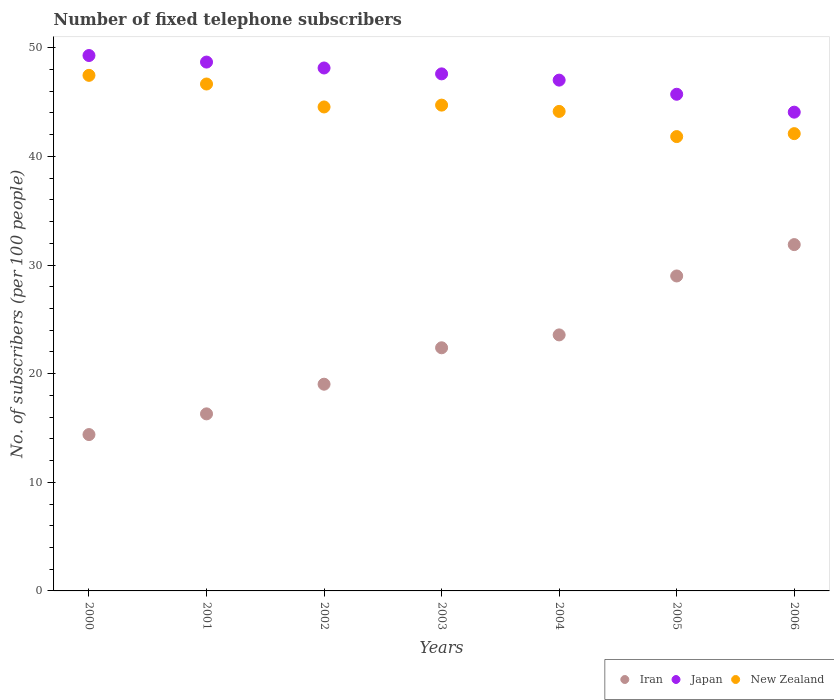Is the number of dotlines equal to the number of legend labels?
Your answer should be very brief. Yes. What is the number of fixed telephone subscribers in New Zealand in 2003?
Make the answer very short. 44.72. Across all years, what is the maximum number of fixed telephone subscribers in New Zealand?
Provide a succinct answer. 47.46. Across all years, what is the minimum number of fixed telephone subscribers in New Zealand?
Offer a very short reply. 41.82. In which year was the number of fixed telephone subscribers in New Zealand minimum?
Ensure brevity in your answer.  2005. What is the total number of fixed telephone subscribers in Japan in the graph?
Offer a terse response. 330.51. What is the difference between the number of fixed telephone subscribers in New Zealand in 2000 and that in 2004?
Give a very brief answer. 3.32. What is the difference between the number of fixed telephone subscribers in Iran in 2003 and the number of fixed telephone subscribers in New Zealand in 2001?
Give a very brief answer. -24.28. What is the average number of fixed telephone subscribers in Iran per year?
Offer a terse response. 22.36. In the year 2004, what is the difference between the number of fixed telephone subscribers in New Zealand and number of fixed telephone subscribers in Iran?
Your answer should be compact. 20.57. In how many years, is the number of fixed telephone subscribers in New Zealand greater than 14?
Ensure brevity in your answer.  7. What is the ratio of the number of fixed telephone subscribers in Japan in 2000 to that in 2005?
Your response must be concise. 1.08. Is the difference between the number of fixed telephone subscribers in New Zealand in 2002 and 2004 greater than the difference between the number of fixed telephone subscribers in Iran in 2002 and 2004?
Offer a very short reply. Yes. What is the difference between the highest and the second highest number of fixed telephone subscribers in Japan?
Offer a very short reply. 0.6. What is the difference between the highest and the lowest number of fixed telephone subscribers in Japan?
Provide a succinct answer. 5.21. In how many years, is the number of fixed telephone subscribers in New Zealand greater than the average number of fixed telephone subscribers in New Zealand taken over all years?
Your answer should be compact. 4. Is the sum of the number of fixed telephone subscribers in Japan in 2003 and 2005 greater than the maximum number of fixed telephone subscribers in Iran across all years?
Give a very brief answer. Yes. Is it the case that in every year, the sum of the number of fixed telephone subscribers in Japan and number of fixed telephone subscribers in New Zealand  is greater than the number of fixed telephone subscribers in Iran?
Your answer should be very brief. Yes. Is the number of fixed telephone subscribers in Iran strictly greater than the number of fixed telephone subscribers in New Zealand over the years?
Offer a terse response. No. Is the number of fixed telephone subscribers in Japan strictly less than the number of fixed telephone subscribers in New Zealand over the years?
Give a very brief answer. No. How many years are there in the graph?
Provide a succinct answer. 7. Are the values on the major ticks of Y-axis written in scientific E-notation?
Your response must be concise. No. Does the graph contain any zero values?
Keep it short and to the point. No. Does the graph contain grids?
Ensure brevity in your answer.  No. Where does the legend appear in the graph?
Provide a succinct answer. Bottom right. What is the title of the graph?
Give a very brief answer. Number of fixed telephone subscribers. What is the label or title of the X-axis?
Provide a short and direct response. Years. What is the label or title of the Y-axis?
Make the answer very short. No. of subscribers (per 100 people). What is the No. of subscribers (per 100 people) of Iran in 2000?
Keep it short and to the point. 14.39. What is the No. of subscribers (per 100 people) in Japan in 2000?
Offer a terse response. 49.28. What is the No. of subscribers (per 100 people) in New Zealand in 2000?
Your response must be concise. 47.46. What is the No. of subscribers (per 100 people) in Iran in 2001?
Your response must be concise. 16.3. What is the No. of subscribers (per 100 people) in Japan in 2001?
Provide a succinct answer. 48.68. What is the No. of subscribers (per 100 people) in New Zealand in 2001?
Your answer should be compact. 46.66. What is the No. of subscribers (per 100 people) of Iran in 2002?
Keep it short and to the point. 19.03. What is the No. of subscribers (per 100 people) of Japan in 2002?
Your answer should be very brief. 48.14. What is the No. of subscribers (per 100 people) in New Zealand in 2002?
Keep it short and to the point. 44.55. What is the No. of subscribers (per 100 people) in Iran in 2003?
Provide a succinct answer. 22.38. What is the No. of subscribers (per 100 people) of Japan in 2003?
Keep it short and to the point. 47.6. What is the No. of subscribers (per 100 people) of New Zealand in 2003?
Provide a succinct answer. 44.72. What is the No. of subscribers (per 100 people) in Iran in 2004?
Offer a very short reply. 23.57. What is the No. of subscribers (per 100 people) of Japan in 2004?
Provide a short and direct response. 47.02. What is the No. of subscribers (per 100 people) of New Zealand in 2004?
Keep it short and to the point. 44.14. What is the No. of subscribers (per 100 people) of Iran in 2005?
Offer a very short reply. 28.99. What is the No. of subscribers (per 100 people) of Japan in 2005?
Your response must be concise. 45.72. What is the No. of subscribers (per 100 people) of New Zealand in 2005?
Offer a terse response. 41.82. What is the No. of subscribers (per 100 people) of Iran in 2006?
Your answer should be very brief. 31.88. What is the No. of subscribers (per 100 people) in Japan in 2006?
Provide a short and direct response. 44.07. What is the No. of subscribers (per 100 people) in New Zealand in 2006?
Provide a short and direct response. 42.09. Across all years, what is the maximum No. of subscribers (per 100 people) of Iran?
Give a very brief answer. 31.88. Across all years, what is the maximum No. of subscribers (per 100 people) of Japan?
Provide a succinct answer. 49.28. Across all years, what is the maximum No. of subscribers (per 100 people) of New Zealand?
Give a very brief answer. 47.46. Across all years, what is the minimum No. of subscribers (per 100 people) in Iran?
Make the answer very short. 14.39. Across all years, what is the minimum No. of subscribers (per 100 people) in Japan?
Offer a terse response. 44.07. Across all years, what is the minimum No. of subscribers (per 100 people) of New Zealand?
Offer a terse response. 41.82. What is the total No. of subscribers (per 100 people) in Iran in the graph?
Your answer should be compact. 156.54. What is the total No. of subscribers (per 100 people) in Japan in the graph?
Provide a succinct answer. 330.51. What is the total No. of subscribers (per 100 people) in New Zealand in the graph?
Ensure brevity in your answer.  311.45. What is the difference between the No. of subscribers (per 100 people) of Iran in 2000 and that in 2001?
Offer a very short reply. -1.91. What is the difference between the No. of subscribers (per 100 people) in Japan in 2000 and that in 2001?
Provide a succinct answer. 0.6. What is the difference between the No. of subscribers (per 100 people) in New Zealand in 2000 and that in 2001?
Your response must be concise. 0.8. What is the difference between the No. of subscribers (per 100 people) in Iran in 2000 and that in 2002?
Provide a succinct answer. -4.64. What is the difference between the No. of subscribers (per 100 people) of Japan in 2000 and that in 2002?
Keep it short and to the point. 1.15. What is the difference between the No. of subscribers (per 100 people) in New Zealand in 2000 and that in 2002?
Make the answer very short. 2.91. What is the difference between the No. of subscribers (per 100 people) in Iran in 2000 and that in 2003?
Your answer should be compact. -7.99. What is the difference between the No. of subscribers (per 100 people) in Japan in 2000 and that in 2003?
Offer a very short reply. 1.69. What is the difference between the No. of subscribers (per 100 people) of New Zealand in 2000 and that in 2003?
Your answer should be compact. 2.74. What is the difference between the No. of subscribers (per 100 people) of Iran in 2000 and that in 2004?
Make the answer very short. -9.17. What is the difference between the No. of subscribers (per 100 people) in Japan in 2000 and that in 2004?
Your answer should be very brief. 2.26. What is the difference between the No. of subscribers (per 100 people) of New Zealand in 2000 and that in 2004?
Keep it short and to the point. 3.32. What is the difference between the No. of subscribers (per 100 people) of Iran in 2000 and that in 2005?
Provide a succinct answer. -14.6. What is the difference between the No. of subscribers (per 100 people) in Japan in 2000 and that in 2005?
Your response must be concise. 3.57. What is the difference between the No. of subscribers (per 100 people) in New Zealand in 2000 and that in 2005?
Offer a terse response. 5.64. What is the difference between the No. of subscribers (per 100 people) in Iran in 2000 and that in 2006?
Make the answer very short. -17.49. What is the difference between the No. of subscribers (per 100 people) in Japan in 2000 and that in 2006?
Make the answer very short. 5.21. What is the difference between the No. of subscribers (per 100 people) in New Zealand in 2000 and that in 2006?
Provide a succinct answer. 5.37. What is the difference between the No. of subscribers (per 100 people) of Iran in 2001 and that in 2002?
Your response must be concise. -2.73. What is the difference between the No. of subscribers (per 100 people) of Japan in 2001 and that in 2002?
Keep it short and to the point. 0.54. What is the difference between the No. of subscribers (per 100 people) in New Zealand in 2001 and that in 2002?
Your answer should be very brief. 2.11. What is the difference between the No. of subscribers (per 100 people) in Iran in 2001 and that in 2003?
Offer a very short reply. -6.08. What is the difference between the No. of subscribers (per 100 people) in Japan in 2001 and that in 2003?
Offer a terse response. 1.09. What is the difference between the No. of subscribers (per 100 people) in New Zealand in 2001 and that in 2003?
Offer a very short reply. 1.94. What is the difference between the No. of subscribers (per 100 people) in Iran in 2001 and that in 2004?
Your response must be concise. -7.27. What is the difference between the No. of subscribers (per 100 people) in Japan in 2001 and that in 2004?
Your response must be concise. 1.66. What is the difference between the No. of subscribers (per 100 people) of New Zealand in 2001 and that in 2004?
Provide a short and direct response. 2.52. What is the difference between the No. of subscribers (per 100 people) of Iran in 2001 and that in 2005?
Your answer should be compact. -12.69. What is the difference between the No. of subscribers (per 100 people) of Japan in 2001 and that in 2005?
Your response must be concise. 2.96. What is the difference between the No. of subscribers (per 100 people) of New Zealand in 2001 and that in 2005?
Provide a short and direct response. 4.84. What is the difference between the No. of subscribers (per 100 people) in Iran in 2001 and that in 2006?
Offer a very short reply. -15.58. What is the difference between the No. of subscribers (per 100 people) of Japan in 2001 and that in 2006?
Make the answer very short. 4.61. What is the difference between the No. of subscribers (per 100 people) in New Zealand in 2001 and that in 2006?
Ensure brevity in your answer.  4.57. What is the difference between the No. of subscribers (per 100 people) of Iran in 2002 and that in 2003?
Ensure brevity in your answer.  -3.35. What is the difference between the No. of subscribers (per 100 people) in Japan in 2002 and that in 2003?
Provide a short and direct response. 0.54. What is the difference between the No. of subscribers (per 100 people) in New Zealand in 2002 and that in 2003?
Provide a succinct answer. -0.17. What is the difference between the No. of subscribers (per 100 people) in Iran in 2002 and that in 2004?
Your answer should be compact. -4.54. What is the difference between the No. of subscribers (per 100 people) of Japan in 2002 and that in 2004?
Ensure brevity in your answer.  1.12. What is the difference between the No. of subscribers (per 100 people) of New Zealand in 2002 and that in 2004?
Your response must be concise. 0.41. What is the difference between the No. of subscribers (per 100 people) of Iran in 2002 and that in 2005?
Provide a succinct answer. -9.96. What is the difference between the No. of subscribers (per 100 people) of Japan in 2002 and that in 2005?
Provide a short and direct response. 2.42. What is the difference between the No. of subscribers (per 100 people) of New Zealand in 2002 and that in 2005?
Provide a short and direct response. 2.73. What is the difference between the No. of subscribers (per 100 people) in Iran in 2002 and that in 2006?
Give a very brief answer. -12.85. What is the difference between the No. of subscribers (per 100 people) in Japan in 2002 and that in 2006?
Your response must be concise. 4.07. What is the difference between the No. of subscribers (per 100 people) of New Zealand in 2002 and that in 2006?
Offer a terse response. 2.45. What is the difference between the No. of subscribers (per 100 people) in Iran in 2003 and that in 2004?
Provide a succinct answer. -1.19. What is the difference between the No. of subscribers (per 100 people) of Japan in 2003 and that in 2004?
Keep it short and to the point. 0.58. What is the difference between the No. of subscribers (per 100 people) in New Zealand in 2003 and that in 2004?
Offer a terse response. 0.58. What is the difference between the No. of subscribers (per 100 people) of Iran in 2003 and that in 2005?
Make the answer very short. -6.61. What is the difference between the No. of subscribers (per 100 people) in Japan in 2003 and that in 2005?
Make the answer very short. 1.88. What is the difference between the No. of subscribers (per 100 people) in New Zealand in 2003 and that in 2005?
Offer a terse response. 2.9. What is the difference between the No. of subscribers (per 100 people) in Iran in 2003 and that in 2006?
Provide a succinct answer. -9.5. What is the difference between the No. of subscribers (per 100 people) of Japan in 2003 and that in 2006?
Your answer should be compact. 3.52. What is the difference between the No. of subscribers (per 100 people) in New Zealand in 2003 and that in 2006?
Offer a very short reply. 2.62. What is the difference between the No. of subscribers (per 100 people) in Iran in 2004 and that in 2005?
Provide a succinct answer. -5.43. What is the difference between the No. of subscribers (per 100 people) of Japan in 2004 and that in 2005?
Keep it short and to the point. 1.3. What is the difference between the No. of subscribers (per 100 people) in New Zealand in 2004 and that in 2005?
Give a very brief answer. 2.32. What is the difference between the No. of subscribers (per 100 people) of Iran in 2004 and that in 2006?
Give a very brief answer. -8.31. What is the difference between the No. of subscribers (per 100 people) in Japan in 2004 and that in 2006?
Keep it short and to the point. 2.95. What is the difference between the No. of subscribers (per 100 people) in New Zealand in 2004 and that in 2006?
Offer a very short reply. 2.05. What is the difference between the No. of subscribers (per 100 people) in Iran in 2005 and that in 2006?
Make the answer very short. -2.89. What is the difference between the No. of subscribers (per 100 people) of Japan in 2005 and that in 2006?
Your answer should be very brief. 1.65. What is the difference between the No. of subscribers (per 100 people) in New Zealand in 2005 and that in 2006?
Offer a very short reply. -0.27. What is the difference between the No. of subscribers (per 100 people) of Iran in 2000 and the No. of subscribers (per 100 people) of Japan in 2001?
Keep it short and to the point. -34.29. What is the difference between the No. of subscribers (per 100 people) in Iran in 2000 and the No. of subscribers (per 100 people) in New Zealand in 2001?
Your answer should be very brief. -32.27. What is the difference between the No. of subscribers (per 100 people) in Japan in 2000 and the No. of subscribers (per 100 people) in New Zealand in 2001?
Give a very brief answer. 2.62. What is the difference between the No. of subscribers (per 100 people) in Iran in 2000 and the No. of subscribers (per 100 people) in Japan in 2002?
Offer a very short reply. -33.74. What is the difference between the No. of subscribers (per 100 people) in Iran in 2000 and the No. of subscribers (per 100 people) in New Zealand in 2002?
Your answer should be compact. -30.16. What is the difference between the No. of subscribers (per 100 people) in Japan in 2000 and the No. of subscribers (per 100 people) in New Zealand in 2002?
Your answer should be compact. 4.74. What is the difference between the No. of subscribers (per 100 people) of Iran in 2000 and the No. of subscribers (per 100 people) of Japan in 2003?
Make the answer very short. -33.2. What is the difference between the No. of subscribers (per 100 people) of Iran in 2000 and the No. of subscribers (per 100 people) of New Zealand in 2003?
Your answer should be compact. -30.33. What is the difference between the No. of subscribers (per 100 people) of Japan in 2000 and the No. of subscribers (per 100 people) of New Zealand in 2003?
Make the answer very short. 4.57. What is the difference between the No. of subscribers (per 100 people) of Iran in 2000 and the No. of subscribers (per 100 people) of Japan in 2004?
Offer a terse response. -32.63. What is the difference between the No. of subscribers (per 100 people) of Iran in 2000 and the No. of subscribers (per 100 people) of New Zealand in 2004?
Make the answer very short. -29.75. What is the difference between the No. of subscribers (per 100 people) in Japan in 2000 and the No. of subscribers (per 100 people) in New Zealand in 2004?
Keep it short and to the point. 5.14. What is the difference between the No. of subscribers (per 100 people) of Iran in 2000 and the No. of subscribers (per 100 people) of Japan in 2005?
Your answer should be very brief. -31.33. What is the difference between the No. of subscribers (per 100 people) of Iran in 2000 and the No. of subscribers (per 100 people) of New Zealand in 2005?
Your answer should be compact. -27.43. What is the difference between the No. of subscribers (per 100 people) of Japan in 2000 and the No. of subscribers (per 100 people) of New Zealand in 2005?
Make the answer very short. 7.46. What is the difference between the No. of subscribers (per 100 people) of Iran in 2000 and the No. of subscribers (per 100 people) of Japan in 2006?
Provide a succinct answer. -29.68. What is the difference between the No. of subscribers (per 100 people) in Iran in 2000 and the No. of subscribers (per 100 people) in New Zealand in 2006?
Your answer should be compact. -27.7. What is the difference between the No. of subscribers (per 100 people) in Japan in 2000 and the No. of subscribers (per 100 people) in New Zealand in 2006?
Keep it short and to the point. 7.19. What is the difference between the No. of subscribers (per 100 people) in Iran in 2001 and the No. of subscribers (per 100 people) in Japan in 2002?
Provide a short and direct response. -31.84. What is the difference between the No. of subscribers (per 100 people) in Iran in 2001 and the No. of subscribers (per 100 people) in New Zealand in 2002?
Your answer should be very brief. -28.25. What is the difference between the No. of subscribers (per 100 people) in Japan in 2001 and the No. of subscribers (per 100 people) in New Zealand in 2002?
Give a very brief answer. 4.13. What is the difference between the No. of subscribers (per 100 people) of Iran in 2001 and the No. of subscribers (per 100 people) of Japan in 2003?
Provide a succinct answer. -31.3. What is the difference between the No. of subscribers (per 100 people) of Iran in 2001 and the No. of subscribers (per 100 people) of New Zealand in 2003?
Ensure brevity in your answer.  -28.42. What is the difference between the No. of subscribers (per 100 people) in Japan in 2001 and the No. of subscribers (per 100 people) in New Zealand in 2003?
Your answer should be very brief. 3.96. What is the difference between the No. of subscribers (per 100 people) in Iran in 2001 and the No. of subscribers (per 100 people) in Japan in 2004?
Offer a very short reply. -30.72. What is the difference between the No. of subscribers (per 100 people) of Iran in 2001 and the No. of subscribers (per 100 people) of New Zealand in 2004?
Keep it short and to the point. -27.84. What is the difference between the No. of subscribers (per 100 people) in Japan in 2001 and the No. of subscribers (per 100 people) in New Zealand in 2004?
Your answer should be compact. 4.54. What is the difference between the No. of subscribers (per 100 people) in Iran in 2001 and the No. of subscribers (per 100 people) in Japan in 2005?
Provide a short and direct response. -29.42. What is the difference between the No. of subscribers (per 100 people) in Iran in 2001 and the No. of subscribers (per 100 people) in New Zealand in 2005?
Ensure brevity in your answer.  -25.52. What is the difference between the No. of subscribers (per 100 people) of Japan in 2001 and the No. of subscribers (per 100 people) of New Zealand in 2005?
Your answer should be compact. 6.86. What is the difference between the No. of subscribers (per 100 people) of Iran in 2001 and the No. of subscribers (per 100 people) of Japan in 2006?
Your answer should be very brief. -27.77. What is the difference between the No. of subscribers (per 100 people) of Iran in 2001 and the No. of subscribers (per 100 people) of New Zealand in 2006?
Ensure brevity in your answer.  -25.8. What is the difference between the No. of subscribers (per 100 people) in Japan in 2001 and the No. of subscribers (per 100 people) in New Zealand in 2006?
Give a very brief answer. 6.59. What is the difference between the No. of subscribers (per 100 people) in Iran in 2002 and the No. of subscribers (per 100 people) in Japan in 2003?
Provide a short and direct response. -28.57. What is the difference between the No. of subscribers (per 100 people) of Iran in 2002 and the No. of subscribers (per 100 people) of New Zealand in 2003?
Your response must be concise. -25.69. What is the difference between the No. of subscribers (per 100 people) of Japan in 2002 and the No. of subscribers (per 100 people) of New Zealand in 2003?
Your answer should be very brief. 3.42. What is the difference between the No. of subscribers (per 100 people) in Iran in 2002 and the No. of subscribers (per 100 people) in Japan in 2004?
Offer a very short reply. -27.99. What is the difference between the No. of subscribers (per 100 people) of Iran in 2002 and the No. of subscribers (per 100 people) of New Zealand in 2004?
Make the answer very short. -25.11. What is the difference between the No. of subscribers (per 100 people) of Japan in 2002 and the No. of subscribers (per 100 people) of New Zealand in 2004?
Provide a succinct answer. 4. What is the difference between the No. of subscribers (per 100 people) in Iran in 2002 and the No. of subscribers (per 100 people) in Japan in 2005?
Ensure brevity in your answer.  -26.69. What is the difference between the No. of subscribers (per 100 people) of Iran in 2002 and the No. of subscribers (per 100 people) of New Zealand in 2005?
Your response must be concise. -22.79. What is the difference between the No. of subscribers (per 100 people) in Japan in 2002 and the No. of subscribers (per 100 people) in New Zealand in 2005?
Provide a succinct answer. 6.31. What is the difference between the No. of subscribers (per 100 people) in Iran in 2002 and the No. of subscribers (per 100 people) in Japan in 2006?
Your response must be concise. -25.04. What is the difference between the No. of subscribers (per 100 people) in Iran in 2002 and the No. of subscribers (per 100 people) in New Zealand in 2006?
Make the answer very short. -23.07. What is the difference between the No. of subscribers (per 100 people) of Japan in 2002 and the No. of subscribers (per 100 people) of New Zealand in 2006?
Provide a short and direct response. 6.04. What is the difference between the No. of subscribers (per 100 people) of Iran in 2003 and the No. of subscribers (per 100 people) of Japan in 2004?
Keep it short and to the point. -24.64. What is the difference between the No. of subscribers (per 100 people) of Iran in 2003 and the No. of subscribers (per 100 people) of New Zealand in 2004?
Provide a succinct answer. -21.76. What is the difference between the No. of subscribers (per 100 people) in Japan in 2003 and the No. of subscribers (per 100 people) in New Zealand in 2004?
Your response must be concise. 3.46. What is the difference between the No. of subscribers (per 100 people) of Iran in 2003 and the No. of subscribers (per 100 people) of Japan in 2005?
Your answer should be very brief. -23.34. What is the difference between the No. of subscribers (per 100 people) in Iran in 2003 and the No. of subscribers (per 100 people) in New Zealand in 2005?
Give a very brief answer. -19.44. What is the difference between the No. of subscribers (per 100 people) of Japan in 2003 and the No. of subscribers (per 100 people) of New Zealand in 2005?
Keep it short and to the point. 5.77. What is the difference between the No. of subscribers (per 100 people) of Iran in 2003 and the No. of subscribers (per 100 people) of Japan in 2006?
Ensure brevity in your answer.  -21.69. What is the difference between the No. of subscribers (per 100 people) of Iran in 2003 and the No. of subscribers (per 100 people) of New Zealand in 2006?
Make the answer very short. -19.71. What is the difference between the No. of subscribers (per 100 people) in Japan in 2003 and the No. of subscribers (per 100 people) in New Zealand in 2006?
Offer a very short reply. 5.5. What is the difference between the No. of subscribers (per 100 people) in Iran in 2004 and the No. of subscribers (per 100 people) in Japan in 2005?
Keep it short and to the point. -22.15. What is the difference between the No. of subscribers (per 100 people) of Iran in 2004 and the No. of subscribers (per 100 people) of New Zealand in 2005?
Keep it short and to the point. -18.26. What is the difference between the No. of subscribers (per 100 people) in Japan in 2004 and the No. of subscribers (per 100 people) in New Zealand in 2005?
Offer a terse response. 5.2. What is the difference between the No. of subscribers (per 100 people) in Iran in 2004 and the No. of subscribers (per 100 people) in Japan in 2006?
Provide a succinct answer. -20.5. What is the difference between the No. of subscribers (per 100 people) of Iran in 2004 and the No. of subscribers (per 100 people) of New Zealand in 2006?
Your answer should be compact. -18.53. What is the difference between the No. of subscribers (per 100 people) in Japan in 2004 and the No. of subscribers (per 100 people) in New Zealand in 2006?
Your answer should be very brief. 4.93. What is the difference between the No. of subscribers (per 100 people) of Iran in 2005 and the No. of subscribers (per 100 people) of Japan in 2006?
Offer a terse response. -15.08. What is the difference between the No. of subscribers (per 100 people) of Iran in 2005 and the No. of subscribers (per 100 people) of New Zealand in 2006?
Offer a terse response. -13.1. What is the difference between the No. of subscribers (per 100 people) of Japan in 2005 and the No. of subscribers (per 100 people) of New Zealand in 2006?
Offer a very short reply. 3.62. What is the average No. of subscribers (per 100 people) in Iran per year?
Provide a short and direct response. 22.36. What is the average No. of subscribers (per 100 people) in Japan per year?
Make the answer very short. 47.22. What is the average No. of subscribers (per 100 people) in New Zealand per year?
Your answer should be very brief. 44.49. In the year 2000, what is the difference between the No. of subscribers (per 100 people) in Iran and No. of subscribers (per 100 people) in Japan?
Your answer should be very brief. -34.89. In the year 2000, what is the difference between the No. of subscribers (per 100 people) in Iran and No. of subscribers (per 100 people) in New Zealand?
Offer a very short reply. -33.07. In the year 2000, what is the difference between the No. of subscribers (per 100 people) of Japan and No. of subscribers (per 100 people) of New Zealand?
Keep it short and to the point. 1.82. In the year 2001, what is the difference between the No. of subscribers (per 100 people) of Iran and No. of subscribers (per 100 people) of Japan?
Provide a short and direct response. -32.38. In the year 2001, what is the difference between the No. of subscribers (per 100 people) of Iran and No. of subscribers (per 100 people) of New Zealand?
Keep it short and to the point. -30.36. In the year 2001, what is the difference between the No. of subscribers (per 100 people) in Japan and No. of subscribers (per 100 people) in New Zealand?
Ensure brevity in your answer.  2.02. In the year 2002, what is the difference between the No. of subscribers (per 100 people) of Iran and No. of subscribers (per 100 people) of Japan?
Make the answer very short. -29.11. In the year 2002, what is the difference between the No. of subscribers (per 100 people) of Iran and No. of subscribers (per 100 people) of New Zealand?
Keep it short and to the point. -25.52. In the year 2002, what is the difference between the No. of subscribers (per 100 people) in Japan and No. of subscribers (per 100 people) in New Zealand?
Give a very brief answer. 3.59. In the year 2003, what is the difference between the No. of subscribers (per 100 people) of Iran and No. of subscribers (per 100 people) of Japan?
Keep it short and to the point. -25.21. In the year 2003, what is the difference between the No. of subscribers (per 100 people) in Iran and No. of subscribers (per 100 people) in New Zealand?
Ensure brevity in your answer.  -22.34. In the year 2003, what is the difference between the No. of subscribers (per 100 people) in Japan and No. of subscribers (per 100 people) in New Zealand?
Your response must be concise. 2.88. In the year 2004, what is the difference between the No. of subscribers (per 100 people) in Iran and No. of subscribers (per 100 people) in Japan?
Keep it short and to the point. -23.45. In the year 2004, what is the difference between the No. of subscribers (per 100 people) of Iran and No. of subscribers (per 100 people) of New Zealand?
Your response must be concise. -20.57. In the year 2004, what is the difference between the No. of subscribers (per 100 people) of Japan and No. of subscribers (per 100 people) of New Zealand?
Ensure brevity in your answer.  2.88. In the year 2005, what is the difference between the No. of subscribers (per 100 people) in Iran and No. of subscribers (per 100 people) in Japan?
Ensure brevity in your answer.  -16.73. In the year 2005, what is the difference between the No. of subscribers (per 100 people) of Iran and No. of subscribers (per 100 people) of New Zealand?
Your answer should be very brief. -12.83. In the year 2005, what is the difference between the No. of subscribers (per 100 people) in Japan and No. of subscribers (per 100 people) in New Zealand?
Make the answer very short. 3.9. In the year 2006, what is the difference between the No. of subscribers (per 100 people) of Iran and No. of subscribers (per 100 people) of Japan?
Your answer should be very brief. -12.19. In the year 2006, what is the difference between the No. of subscribers (per 100 people) in Iran and No. of subscribers (per 100 people) in New Zealand?
Provide a succinct answer. -10.21. In the year 2006, what is the difference between the No. of subscribers (per 100 people) in Japan and No. of subscribers (per 100 people) in New Zealand?
Make the answer very short. 1.98. What is the ratio of the No. of subscribers (per 100 people) in Iran in 2000 to that in 2001?
Give a very brief answer. 0.88. What is the ratio of the No. of subscribers (per 100 people) in Japan in 2000 to that in 2001?
Your response must be concise. 1.01. What is the ratio of the No. of subscribers (per 100 people) of New Zealand in 2000 to that in 2001?
Provide a short and direct response. 1.02. What is the ratio of the No. of subscribers (per 100 people) in Iran in 2000 to that in 2002?
Provide a succinct answer. 0.76. What is the ratio of the No. of subscribers (per 100 people) in Japan in 2000 to that in 2002?
Your response must be concise. 1.02. What is the ratio of the No. of subscribers (per 100 people) of New Zealand in 2000 to that in 2002?
Provide a short and direct response. 1.07. What is the ratio of the No. of subscribers (per 100 people) of Iran in 2000 to that in 2003?
Keep it short and to the point. 0.64. What is the ratio of the No. of subscribers (per 100 people) of Japan in 2000 to that in 2003?
Offer a terse response. 1.04. What is the ratio of the No. of subscribers (per 100 people) in New Zealand in 2000 to that in 2003?
Your answer should be compact. 1.06. What is the ratio of the No. of subscribers (per 100 people) in Iran in 2000 to that in 2004?
Ensure brevity in your answer.  0.61. What is the ratio of the No. of subscribers (per 100 people) in Japan in 2000 to that in 2004?
Your answer should be very brief. 1.05. What is the ratio of the No. of subscribers (per 100 people) in New Zealand in 2000 to that in 2004?
Your response must be concise. 1.08. What is the ratio of the No. of subscribers (per 100 people) of Iran in 2000 to that in 2005?
Keep it short and to the point. 0.5. What is the ratio of the No. of subscribers (per 100 people) of Japan in 2000 to that in 2005?
Provide a short and direct response. 1.08. What is the ratio of the No. of subscribers (per 100 people) of New Zealand in 2000 to that in 2005?
Give a very brief answer. 1.13. What is the ratio of the No. of subscribers (per 100 people) in Iran in 2000 to that in 2006?
Provide a succinct answer. 0.45. What is the ratio of the No. of subscribers (per 100 people) in Japan in 2000 to that in 2006?
Your answer should be very brief. 1.12. What is the ratio of the No. of subscribers (per 100 people) in New Zealand in 2000 to that in 2006?
Provide a succinct answer. 1.13. What is the ratio of the No. of subscribers (per 100 people) in Iran in 2001 to that in 2002?
Your answer should be very brief. 0.86. What is the ratio of the No. of subscribers (per 100 people) of Japan in 2001 to that in 2002?
Ensure brevity in your answer.  1.01. What is the ratio of the No. of subscribers (per 100 people) in New Zealand in 2001 to that in 2002?
Give a very brief answer. 1.05. What is the ratio of the No. of subscribers (per 100 people) in Iran in 2001 to that in 2003?
Provide a succinct answer. 0.73. What is the ratio of the No. of subscribers (per 100 people) of Japan in 2001 to that in 2003?
Keep it short and to the point. 1.02. What is the ratio of the No. of subscribers (per 100 people) of New Zealand in 2001 to that in 2003?
Offer a very short reply. 1.04. What is the ratio of the No. of subscribers (per 100 people) in Iran in 2001 to that in 2004?
Your response must be concise. 0.69. What is the ratio of the No. of subscribers (per 100 people) in Japan in 2001 to that in 2004?
Offer a very short reply. 1.04. What is the ratio of the No. of subscribers (per 100 people) of New Zealand in 2001 to that in 2004?
Keep it short and to the point. 1.06. What is the ratio of the No. of subscribers (per 100 people) in Iran in 2001 to that in 2005?
Provide a succinct answer. 0.56. What is the ratio of the No. of subscribers (per 100 people) in Japan in 2001 to that in 2005?
Your answer should be compact. 1.06. What is the ratio of the No. of subscribers (per 100 people) of New Zealand in 2001 to that in 2005?
Ensure brevity in your answer.  1.12. What is the ratio of the No. of subscribers (per 100 people) in Iran in 2001 to that in 2006?
Ensure brevity in your answer.  0.51. What is the ratio of the No. of subscribers (per 100 people) in Japan in 2001 to that in 2006?
Keep it short and to the point. 1.1. What is the ratio of the No. of subscribers (per 100 people) in New Zealand in 2001 to that in 2006?
Offer a very short reply. 1.11. What is the ratio of the No. of subscribers (per 100 people) in Iran in 2002 to that in 2003?
Keep it short and to the point. 0.85. What is the ratio of the No. of subscribers (per 100 people) of Japan in 2002 to that in 2003?
Offer a very short reply. 1.01. What is the ratio of the No. of subscribers (per 100 people) in Iran in 2002 to that in 2004?
Your answer should be compact. 0.81. What is the ratio of the No. of subscribers (per 100 people) of Japan in 2002 to that in 2004?
Your answer should be compact. 1.02. What is the ratio of the No. of subscribers (per 100 people) of New Zealand in 2002 to that in 2004?
Your answer should be compact. 1.01. What is the ratio of the No. of subscribers (per 100 people) in Iran in 2002 to that in 2005?
Keep it short and to the point. 0.66. What is the ratio of the No. of subscribers (per 100 people) of Japan in 2002 to that in 2005?
Offer a terse response. 1.05. What is the ratio of the No. of subscribers (per 100 people) of New Zealand in 2002 to that in 2005?
Provide a succinct answer. 1.07. What is the ratio of the No. of subscribers (per 100 people) in Iran in 2002 to that in 2006?
Offer a very short reply. 0.6. What is the ratio of the No. of subscribers (per 100 people) of Japan in 2002 to that in 2006?
Provide a succinct answer. 1.09. What is the ratio of the No. of subscribers (per 100 people) of New Zealand in 2002 to that in 2006?
Provide a succinct answer. 1.06. What is the ratio of the No. of subscribers (per 100 people) in Iran in 2003 to that in 2004?
Your response must be concise. 0.95. What is the ratio of the No. of subscribers (per 100 people) in Japan in 2003 to that in 2004?
Offer a terse response. 1.01. What is the ratio of the No. of subscribers (per 100 people) of New Zealand in 2003 to that in 2004?
Give a very brief answer. 1.01. What is the ratio of the No. of subscribers (per 100 people) of Iran in 2003 to that in 2005?
Make the answer very short. 0.77. What is the ratio of the No. of subscribers (per 100 people) of Japan in 2003 to that in 2005?
Offer a terse response. 1.04. What is the ratio of the No. of subscribers (per 100 people) of New Zealand in 2003 to that in 2005?
Provide a short and direct response. 1.07. What is the ratio of the No. of subscribers (per 100 people) of Iran in 2003 to that in 2006?
Your answer should be very brief. 0.7. What is the ratio of the No. of subscribers (per 100 people) of New Zealand in 2003 to that in 2006?
Keep it short and to the point. 1.06. What is the ratio of the No. of subscribers (per 100 people) in Iran in 2004 to that in 2005?
Keep it short and to the point. 0.81. What is the ratio of the No. of subscribers (per 100 people) in Japan in 2004 to that in 2005?
Your answer should be compact. 1.03. What is the ratio of the No. of subscribers (per 100 people) in New Zealand in 2004 to that in 2005?
Give a very brief answer. 1.06. What is the ratio of the No. of subscribers (per 100 people) of Iran in 2004 to that in 2006?
Provide a short and direct response. 0.74. What is the ratio of the No. of subscribers (per 100 people) in Japan in 2004 to that in 2006?
Your response must be concise. 1.07. What is the ratio of the No. of subscribers (per 100 people) of New Zealand in 2004 to that in 2006?
Your response must be concise. 1.05. What is the ratio of the No. of subscribers (per 100 people) in Iran in 2005 to that in 2006?
Keep it short and to the point. 0.91. What is the ratio of the No. of subscribers (per 100 people) of Japan in 2005 to that in 2006?
Give a very brief answer. 1.04. What is the ratio of the No. of subscribers (per 100 people) in New Zealand in 2005 to that in 2006?
Provide a succinct answer. 0.99. What is the difference between the highest and the second highest No. of subscribers (per 100 people) in Iran?
Ensure brevity in your answer.  2.89. What is the difference between the highest and the second highest No. of subscribers (per 100 people) of Japan?
Your answer should be compact. 0.6. What is the difference between the highest and the second highest No. of subscribers (per 100 people) of New Zealand?
Make the answer very short. 0.8. What is the difference between the highest and the lowest No. of subscribers (per 100 people) in Iran?
Provide a short and direct response. 17.49. What is the difference between the highest and the lowest No. of subscribers (per 100 people) of Japan?
Your response must be concise. 5.21. What is the difference between the highest and the lowest No. of subscribers (per 100 people) in New Zealand?
Provide a succinct answer. 5.64. 